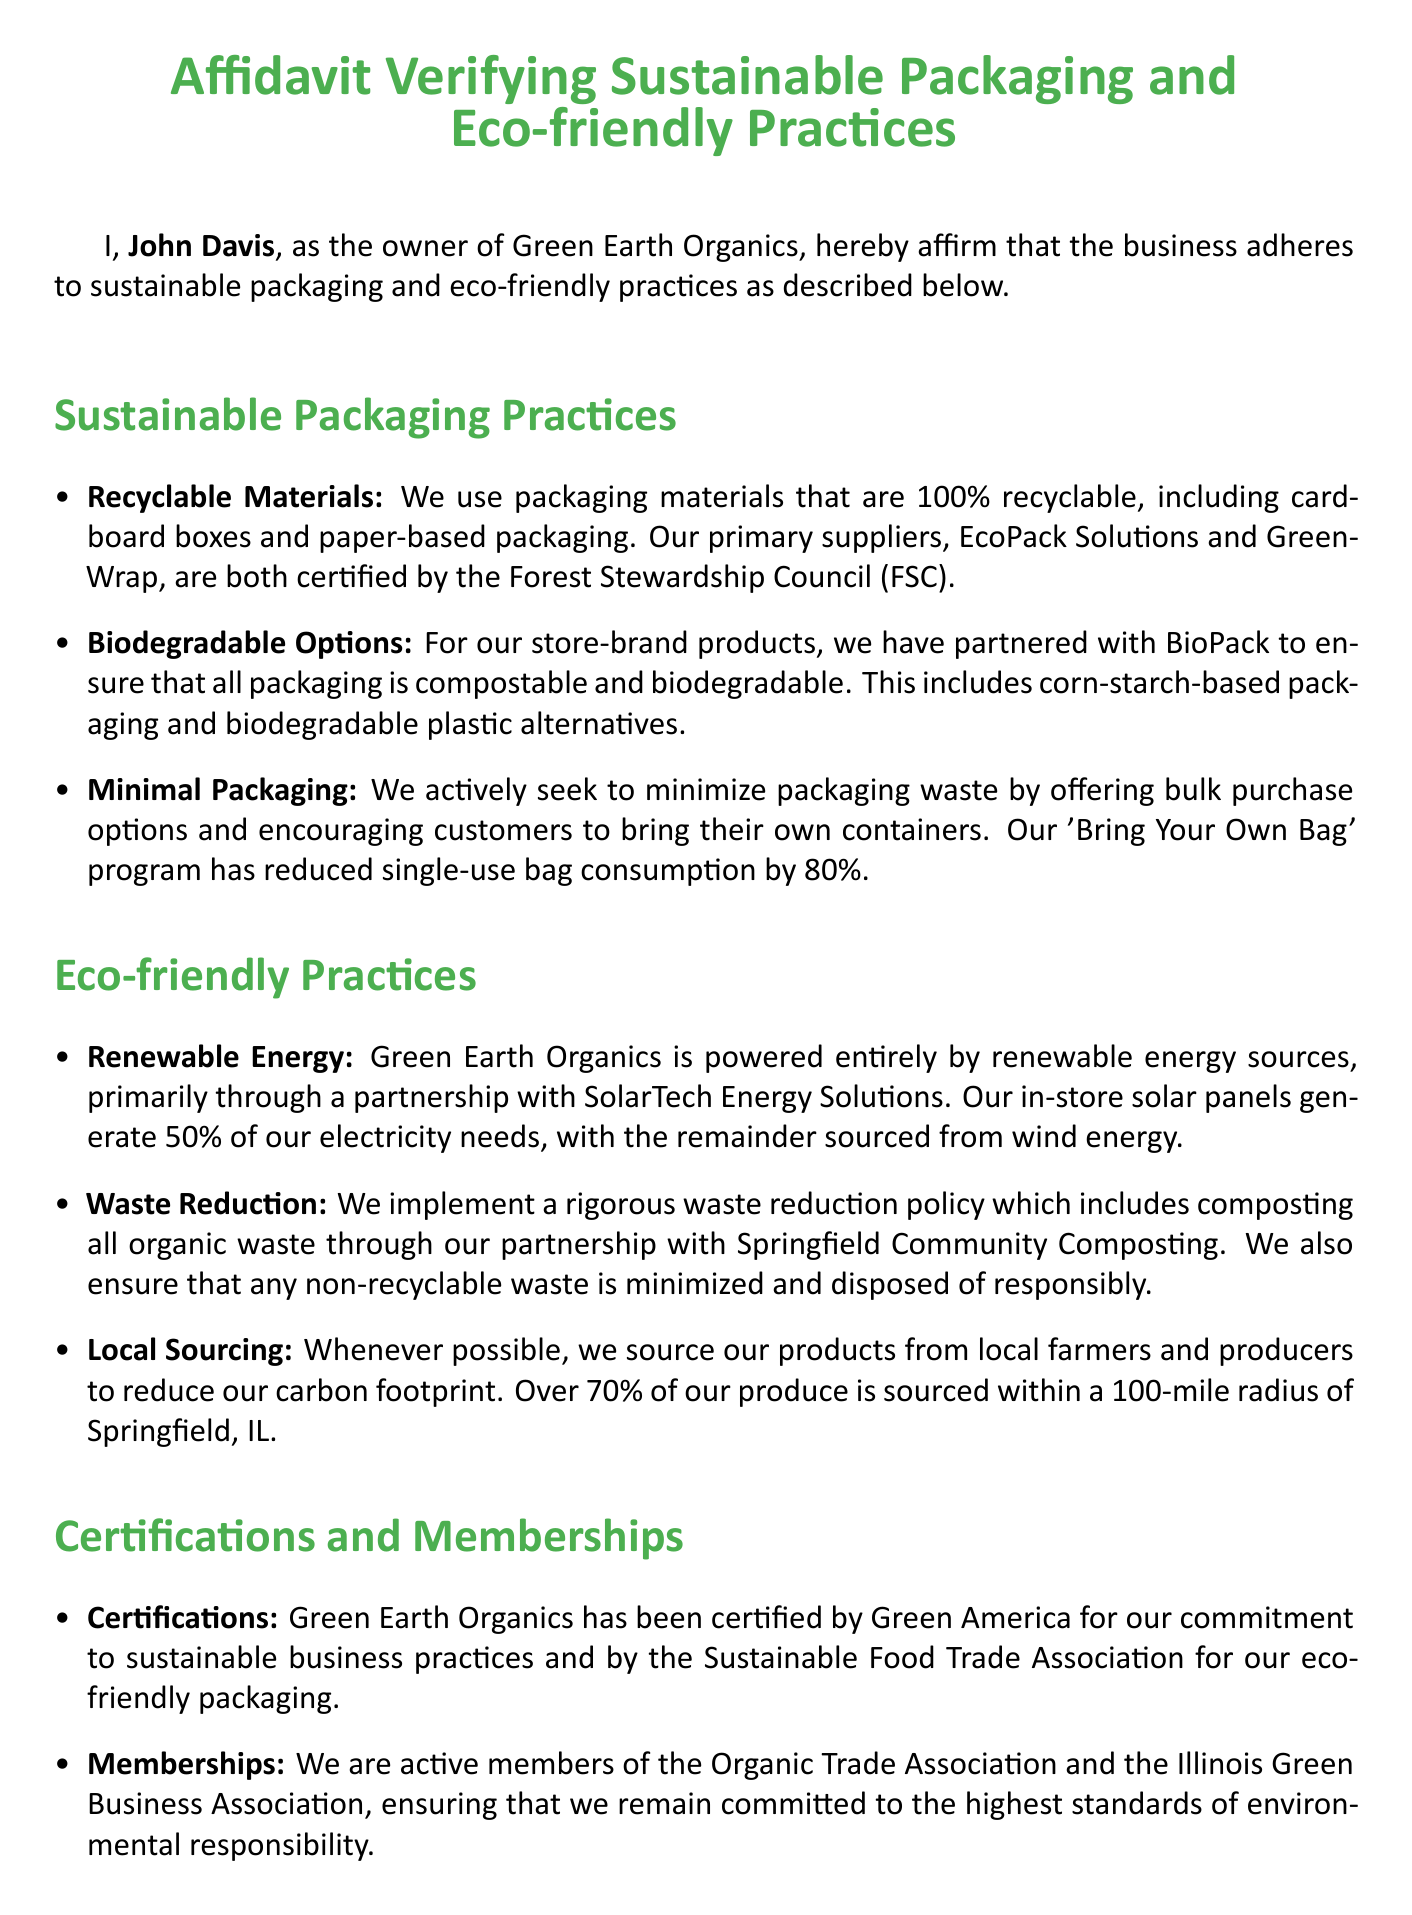what are the recyclable materials used in packaging? The document states that the business uses packaging materials that are 100% recyclable, including cardboard boxes and paper-based packaging.
Answer: cardboard boxes and paper-based packaging who is the owner of Green Earth Organics? The affidavit clearly identifies John Davis as the owner of the business.
Answer: John Davis what percentage of electricity needs is generated by solar panels? The document mentions that the in-store solar panels generate 50% of the electricity needs.
Answer: 50% what program has reduced single-use bag consumption by 80%? The affidavit refers to the 'Bring Your Own Bag' program as the initiative that reduces single-use bag consumption.
Answer: Bring Your Own Bag program which company is partnered with Green Earth Organics for biodegradable packaging? The document states that BioPack is the partnered company for biodegradable packaging.
Answer: BioPack what certification does Green Earth Organics hold for sustainable business practices? The document mentions that Green Earth Organics has been certified by Green America for its commitment to sustainable practices.
Answer: Green America how much of the produce is sourced within a 100-mile radius of Springfield, IL? According to the document, over 70% of the produce is sourced within that radius.
Answer: over 70% what is the date on the affidavit? The affidavit provides the specific date it was signed as November 1, 2023.
Answer: November 1, 2023 which association is mentioned as an active membership of Green Earth Organics? The document lists the Organic Trade Association as one of the associations.
Answer: Organic Trade Association 